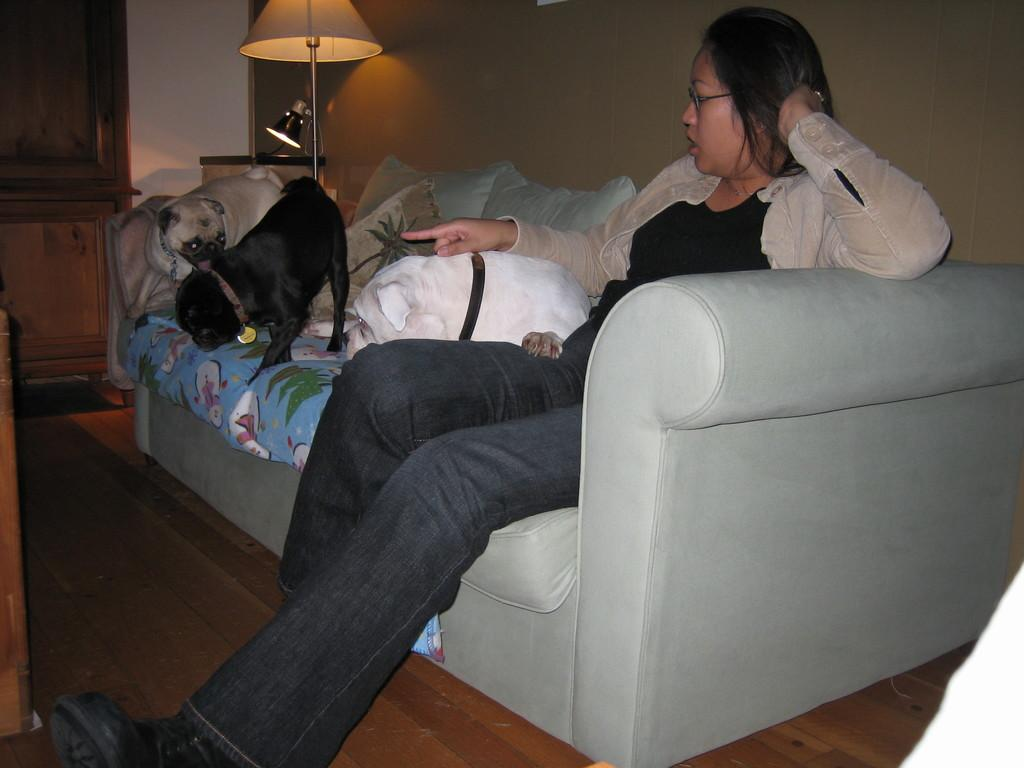How many dogs are present in the image? There are three dogs in the image. What is the woman in the image doing? The woman is sitting on a couch in the image. What can be seen on the couch besides the woman? There are pillows in the image. What type of lighting is present in the image? There is a lamp in the image. What type of furniture is visible in the image? There is a cupboard in the image. What type of heart-shaped object can be seen on the dogs in the image? There is no heart-shaped object present on the dogs in the image. Can you tell me how many owls are sitting on the cupboard in the image? There are no owls present in the image; only the dogs, woman, pillows, lamp, and cupboard are visible. 